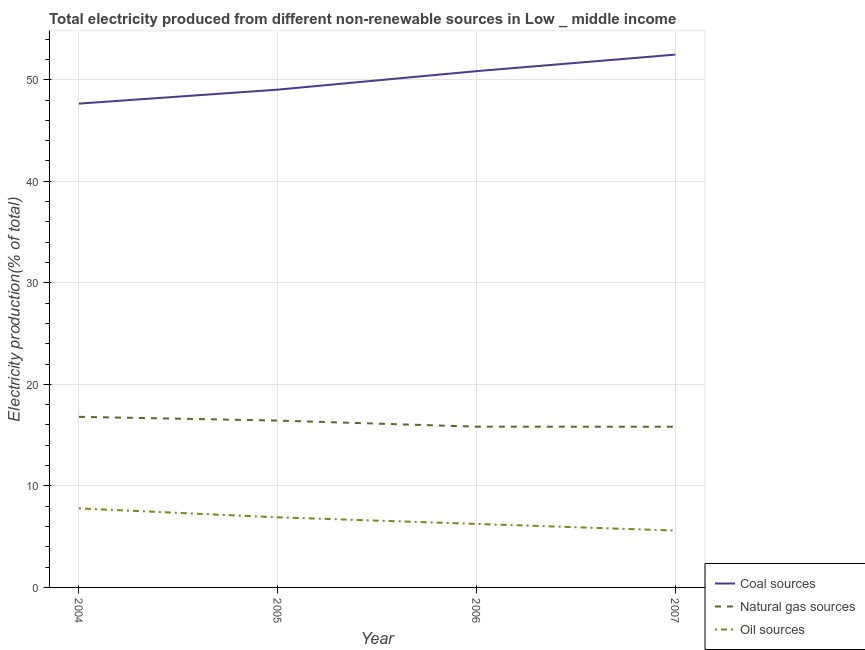How many different coloured lines are there?
Your response must be concise. 3. Does the line corresponding to percentage of electricity produced by natural gas intersect with the line corresponding to percentage of electricity produced by oil sources?
Give a very brief answer. No. What is the percentage of electricity produced by natural gas in 2007?
Keep it short and to the point. 15.83. Across all years, what is the maximum percentage of electricity produced by coal?
Your answer should be very brief. 52.47. Across all years, what is the minimum percentage of electricity produced by natural gas?
Your answer should be very brief. 15.83. In which year was the percentage of electricity produced by oil sources maximum?
Offer a very short reply. 2004. What is the total percentage of electricity produced by natural gas in the graph?
Give a very brief answer. 64.89. What is the difference between the percentage of electricity produced by coal in 2004 and that in 2005?
Offer a terse response. -1.38. What is the difference between the percentage of electricity produced by oil sources in 2007 and the percentage of electricity produced by coal in 2004?
Your answer should be very brief. -42.05. What is the average percentage of electricity produced by natural gas per year?
Offer a very short reply. 16.22. In the year 2005, what is the difference between the percentage of electricity produced by natural gas and percentage of electricity produced by coal?
Offer a terse response. -32.59. In how many years, is the percentage of electricity produced by oil sources greater than 48 %?
Ensure brevity in your answer.  0. What is the ratio of the percentage of electricity produced by oil sources in 2004 to that in 2005?
Provide a short and direct response. 1.13. Is the difference between the percentage of electricity produced by natural gas in 2005 and 2006 greater than the difference between the percentage of electricity produced by coal in 2005 and 2006?
Ensure brevity in your answer.  Yes. What is the difference between the highest and the second highest percentage of electricity produced by coal?
Provide a succinct answer. 1.63. What is the difference between the highest and the lowest percentage of electricity produced by coal?
Your answer should be compact. 4.82. Does the percentage of electricity produced by coal monotonically increase over the years?
Provide a succinct answer. Yes. Is the percentage of electricity produced by coal strictly greater than the percentage of electricity produced by natural gas over the years?
Ensure brevity in your answer.  Yes. How many lines are there?
Provide a succinct answer. 3. What is the difference between two consecutive major ticks on the Y-axis?
Provide a short and direct response. 10. How many legend labels are there?
Your answer should be compact. 3. How are the legend labels stacked?
Provide a succinct answer. Vertical. What is the title of the graph?
Offer a very short reply. Total electricity produced from different non-renewable sources in Low _ middle income. What is the Electricity production(% of total) of Coal sources in 2004?
Make the answer very short. 47.65. What is the Electricity production(% of total) of Natural gas sources in 2004?
Provide a short and direct response. 16.8. What is the Electricity production(% of total) in Oil sources in 2004?
Offer a very short reply. 7.78. What is the Electricity production(% of total) in Coal sources in 2005?
Ensure brevity in your answer.  49.03. What is the Electricity production(% of total) of Natural gas sources in 2005?
Keep it short and to the point. 16.43. What is the Electricity production(% of total) in Oil sources in 2005?
Give a very brief answer. 6.9. What is the Electricity production(% of total) in Coal sources in 2006?
Offer a terse response. 50.85. What is the Electricity production(% of total) in Natural gas sources in 2006?
Give a very brief answer. 15.83. What is the Electricity production(% of total) of Oil sources in 2006?
Offer a very short reply. 6.26. What is the Electricity production(% of total) of Coal sources in 2007?
Keep it short and to the point. 52.47. What is the Electricity production(% of total) in Natural gas sources in 2007?
Provide a short and direct response. 15.83. What is the Electricity production(% of total) in Oil sources in 2007?
Your answer should be very brief. 5.6. Across all years, what is the maximum Electricity production(% of total) of Coal sources?
Keep it short and to the point. 52.47. Across all years, what is the maximum Electricity production(% of total) of Natural gas sources?
Your answer should be very brief. 16.8. Across all years, what is the maximum Electricity production(% of total) of Oil sources?
Keep it short and to the point. 7.78. Across all years, what is the minimum Electricity production(% of total) of Coal sources?
Your answer should be very brief. 47.65. Across all years, what is the minimum Electricity production(% of total) of Natural gas sources?
Your answer should be very brief. 15.83. Across all years, what is the minimum Electricity production(% of total) of Oil sources?
Ensure brevity in your answer.  5.6. What is the total Electricity production(% of total) of Coal sources in the graph?
Your answer should be compact. 200. What is the total Electricity production(% of total) in Natural gas sources in the graph?
Provide a short and direct response. 64.89. What is the total Electricity production(% of total) in Oil sources in the graph?
Your response must be concise. 26.54. What is the difference between the Electricity production(% of total) of Coal sources in 2004 and that in 2005?
Keep it short and to the point. -1.38. What is the difference between the Electricity production(% of total) of Natural gas sources in 2004 and that in 2005?
Your answer should be compact. 0.37. What is the difference between the Electricity production(% of total) in Oil sources in 2004 and that in 2005?
Make the answer very short. 0.88. What is the difference between the Electricity production(% of total) of Coal sources in 2004 and that in 2006?
Keep it short and to the point. -3.2. What is the difference between the Electricity production(% of total) of Natural gas sources in 2004 and that in 2006?
Provide a succinct answer. 0.97. What is the difference between the Electricity production(% of total) in Oil sources in 2004 and that in 2006?
Ensure brevity in your answer.  1.53. What is the difference between the Electricity production(% of total) in Coal sources in 2004 and that in 2007?
Ensure brevity in your answer.  -4.82. What is the difference between the Electricity production(% of total) in Natural gas sources in 2004 and that in 2007?
Your answer should be compact. 0.98. What is the difference between the Electricity production(% of total) in Oil sources in 2004 and that in 2007?
Give a very brief answer. 2.18. What is the difference between the Electricity production(% of total) in Coal sources in 2005 and that in 2006?
Make the answer very short. -1.82. What is the difference between the Electricity production(% of total) of Natural gas sources in 2005 and that in 2006?
Ensure brevity in your answer.  0.6. What is the difference between the Electricity production(% of total) of Oil sources in 2005 and that in 2006?
Make the answer very short. 0.65. What is the difference between the Electricity production(% of total) in Coal sources in 2005 and that in 2007?
Give a very brief answer. -3.45. What is the difference between the Electricity production(% of total) of Natural gas sources in 2005 and that in 2007?
Make the answer very short. 0.61. What is the difference between the Electricity production(% of total) of Oil sources in 2005 and that in 2007?
Give a very brief answer. 1.3. What is the difference between the Electricity production(% of total) in Coal sources in 2006 and that in 2007?
Your answer should be compact. -1.63. What is the difference between the Electricity production(% of total) of Natural gas sources in 2006 and that in 2007?
Keep it short and to the point. 0.01. What is the difference between the Electricity production(% of total) of Oil sources in 2006 and that in 2007?
Give a very brief answer. 0.66. What is the difference between the Electricity production(% of total) in Coal sources in 2004 and the Electricity production(% of total) in Natural gas sources in 2005?
Your response must be concise. 31.22. What is the difference between the Electricity production(% of total) of Coal sources in 2004 and the Electricity production(% of total) of Oil sources in 2005?
Your response must be concise. 40.75. What is the difference between the Electricity production(% of total) of Natural gas sources in 2004 and the Electricity production(% of total) of Oil sources in 2005?
Your answer should be compact. 9.9. What is the difference between the Electricity production(% of total) of Coal sources in 2004 and the Electricity production(% of total) of Natural gas sources in 2006?
Ensure brevity in your answer.  31.82. What is the difference between the Electricity production(% of total) in Coal sources in 2004 and the Electricity production(% of total) in Oil sources in 2006?
Provide a short and direct response. 41.39. What is the difference between the Electricity production(% of total) in Natural gas sources in 2004 and the Electricity production(% of total) in Oil sources in 2006?
Your answer should be very brief. 10.55. What is the difference between the Electricity production(% of total) in Coal sources in 2004 and the Electricity production(% of total) in Natural gas sources in 2007?
Offer a terse response. 31.82. What is the difference between the Electricity production(% of total) in Coal sources in 2004 and the Electricity production(% of total) in Oil sources in 2007?
Provide a succinct answer. 42.05. What is the difference between the Electricity production(% of total) in Natural gas sources in 2004 and the Electricity production(% of total) in Oil sources in 2007?
Provide a succinct answer. 11.2. What is the difference between the Electricity production(% of total) of Coal sources in 2005 and the Electricity production(% of total) of Natural gas sources in 2006?
Your response must be concise. 33.19. What is the difference between the Electricity production(% of total) in Coal sources in 2005 and the Electricity production(% of total) in Oil sources in 2006?
Ensure brevity in your answer.  42.77. What is the difference between the Electricity production(% of total) of Natural gas sources in 2005 and the Electricity production(% of total) of Oil sources in 2006?
Ensure brevity in your answer.  10.18. What is the difference between the Electricity production(% of total) of Coal sources in 2005 and the Electricity production(% of total) of Natural gas sources in 2007?
Your response must be concise. 33.2. What is the difference between the Electricity production(% of total) of Coal sources in 2005 and the Electricity production(% of total) of Oil sources in 2007?
Offer a very short reply. 43.43. What is the difference between the Electricity production(% of total) of Natural gas sources in 2005 and the Electricity production(% of total) of Oil sources in 2007?
Offer a terse response. 10.83. What is the difference between the Electricity production(% of total) of Coal sources in 2006 and the Electricity production(% of total) of Natural gas sources in 2007?
Your response must be concise. 35.02. What is the difference between the Electricity production(% of total) in Coal sources in 2006 and the Electricity production(% of total) in Oil sources in 2007?
Ensure brevity in your answer.  45.25. What is the difference between the Electricity production(% of total) in Natural gas sources in 2006 and the Electricity production(% of total) in Oil sources in 2007?
Offer a terse response. 10.23. What is the average Electricity production(% of total) of Coal sources per year?
Your answer should be very brief. 50. What is the average Electricity production(% of total) in Natural gas sources per year?
Provide a succinct answer. 16.22. What is the average Electricity production(% of total) of Oil sources per year?
Provide a short and direct response. 6.64. In the year 2004, what is the difference between the Electricity production(% of total) of Coal sources and Electricity production(% of total) of Natural gas sources?
Your answer should be very brief. 30.85. In the year 2004, what is the difference between the Electricity production(% of total) in Coal sources and Electricity production(% of total) in Oil sources?
Your answer should be compact. 39.87. In the year 2004, what is the difference between the Electricity production(% of total) in Natural gas sources and Electricity production(% of total) in Oil sources?
Offer a very short reply. 9.02. In the year 2005, what is the difference between the Electricity production(% of total) in Coal sources and Electricity production(% of total) in Natural gas sources?
Your answer should be compact. 32.59. In the year 2005, what is the difference between the Electricity production(% of total) of Coal sources and Electricity production(% of total) of Oil sources?
Provide a succinct answer. 42.12. In the year 2005, what is the difference between the Electricity production(% of total) in Natural gas sources and Electricity production(% of total) in Oil sources?
Provide a short and direct response. 9.53. In the year 2006, what is the difference between the Electricity production(% of total) of Coal sources and Electricity production(% of total) of Natural gas sources?
Ensure brevity in your answer.  35.01. In the year 2006, what is the difference between the Electricity production(% of total) in Coal sources and Electricity production(% of total) in Oil sources?
Provide a succinct answer. 44.59. In the year 2006, what is the difference between the Electricity production(% of total) of Natural gas sources and Electricity production(% of total) of Oil sources?
Your answer should be very brief. 9.58. In the year 2007, what is the difference between the Electricity production(% of total) of Coal sources and Electricity production(% of total) of Natural gas sources?
Ensure brevity in your answer.  36.65. In the year 2007, what is the difference between the Electricity production(% of total) of Coal sources and Electricity production(% of total) of Oil sources?
Make the answer very short. 46.87. In the year 2007, what is the difference between the Electricity production(% of total) of Natural gas sources and Electricity production(% of total) of Oil sources?
Ensure brevity in your answer.  10.23. What is the ratio of the Electricity production(% of total) in Coal sources in 2004 to that in 2005?
Provide a short and direct response. 0.97. What is the ratio of the Electricity production(% of total) of Natural gas sources in 2004 to that in 2005?
Provide a short and direct response. 1.02. What is the ratio of the Electricity production(% of total) in Oil sources in 2004 to that in 2005?
Keep it short and to the point. 1.13. What is the ratio of the Electricity production(% of total) of Coal sources in 2004 to that in 2006?
Keep it short and to the point. 0.94. What is the ratio of the Electricity production(% of total) in Natural gas sources in 2004 to that in 2006?
Your answer should be very brief. 1.06. What is the ratio of the Electricity production(% of total) of Oil sources in 2004 to that in 2006?
Give a very brief answer. 1.24. What is the ratio of the Electricity production(% of total) in Coal sources in 2004 to that in 2007?
Offer a terse response. 0.91. What is the ratio of the Electricity production(% of total) in Natural gas sources in 2004 to that in 2007?
Provide a short and direct response. 1.06. What is the ratio of the Electricity production(% of total) in Oil sources in 2004 to that in 2007?
Provide a short and direct response. 1.39. What is the ratio of the Electricity production(% of total) of Coal sources in 2005 to that in 2006?
Keep it short and to the point. 0.96. What is the ratio of the Electricity production(% of total) in Natural gas sources in 2005 to that in 2006?
Ensure brevity in your answer.  1.04. What is the ratio of the Electricity production(% of total) of Oil sources in 2005 to that in 2006?
Provide a short and direct response. 1.1. What is the ratio of the Electricity production(% of total) in Coal sources in 2005 to that in 2007?
Offer a very short reply. 0.93. What is the ratio of the Electricity production(% of total) in Natural gas sources in 2005 to that in 2007?
Provide a succinct answer. 1.04. What is the ratio of the Electricity production(% of total) of Oil sources in 2005 to that in 2007?
Give a very brief answer. 1.23. What is the ratio of the Electricity production(% of total) of Coal sources in 2006 to that in 2007?
Your answer should be very brief. 0.97. What is the ratio of the Electricity production(% of total) of Natural gas sources in 2006 to that in 2007?
Your answer should be compact. 1. What is the ratio of the Electricity production(% of total) of Oil sources in 2006 to that in 2007?
Your answer should be very brief. 1.12. What is the difference between the highest and the second highest Electricity production(% of total) of Coal sources?
Offer a terse response. 1.63. What is the difference between the highest and the second highest Electricity production(% of total) of Natural gas sources?
Offer a terse response. 0.37. What is the difference between the highest and the second highest Electricity production(% of total) of Oil sources?
Your response must be concise. 0.88. What is the difference between the highest and the lowest Electricity production(% of total) of Coal sources?
Your response must be concise. 4.82. What is the difference between the highest and the lowest Electricity production(% of total) of Natural gas sources?
Offer a very short reply. 0.98. What is the difference between the highest and the lowest Electricity production(% of total) of Oil sources?
Your answer should be very brief. 2.18. 